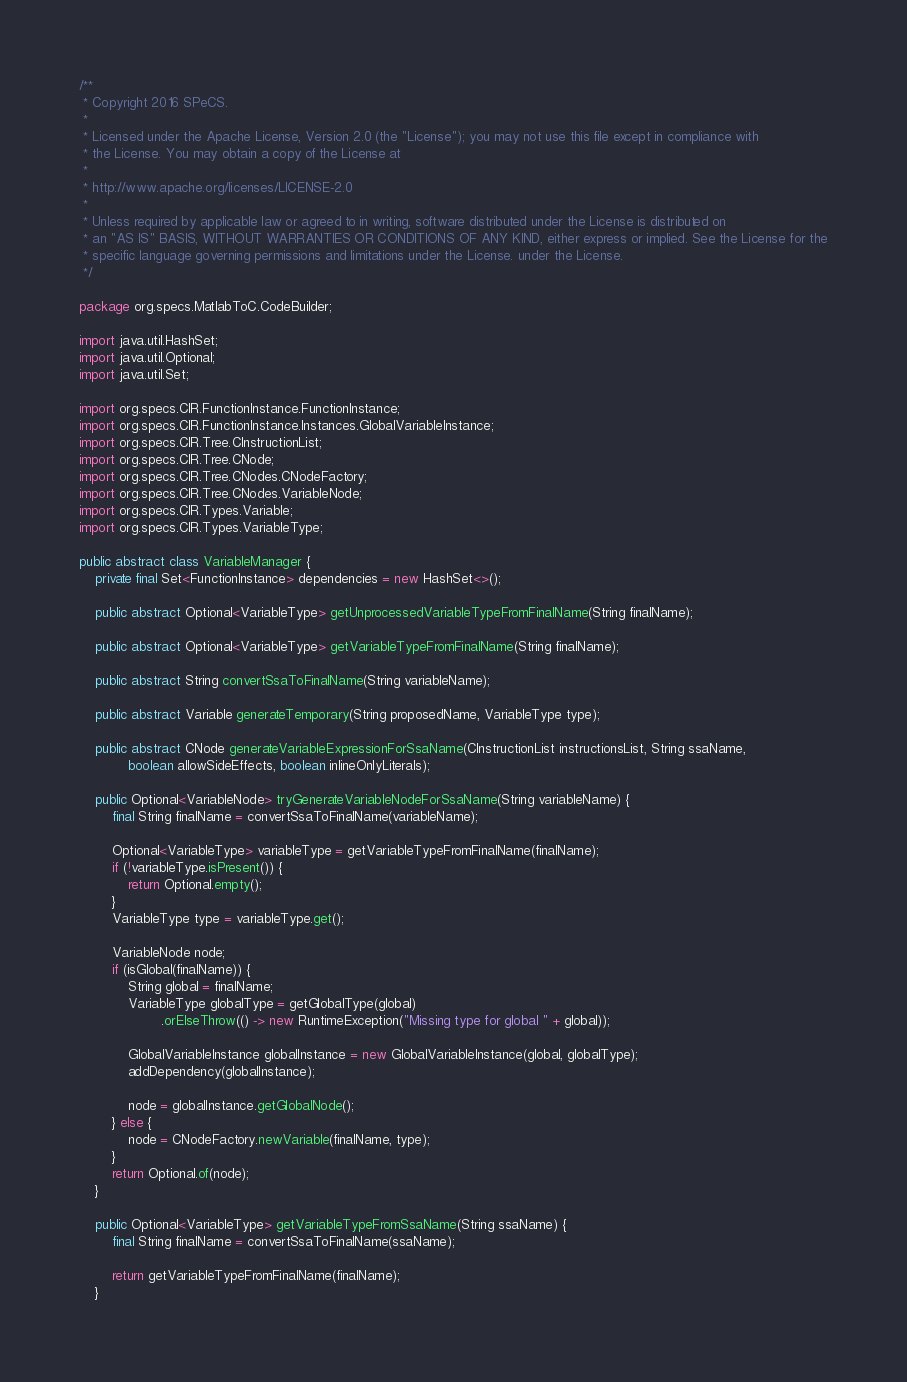Convert code to text. <code><loc_0><loc_0><loc_500><loc_500><_Java_>/**
 * Copyright 2016 SPeCS.
 * 
 * Licensed under the Apache License, Version 2.0 (the "License"); you may not use this file except in compliance with
 * the License. You may obtain a copy of the License at
 * 
 * http://www.apache.org/licenses/LICENSE-2.0
 * 
 * Unless required by applicable law or agreed to in writing, software distributed under the License is distributed on
 * an "AS IS" BASIS, WITHOUT WARRANTIES OR CONDITIONS OF ANY KIND, either express or implied. See the License for the
 * specific language governing permissions and limitations under the License. under the License.
 */

package org.specs.MatlabToC.CodeBuilder;

import java.util.HashSet;
import java.util.Optional;
import java.util.Set;

import org.specs.CIR.FunctionInstance.FunctionInstance;
import org.specs.CIR.FunctionInstance.Instances.GlobalVariableInstance;
import org.specs.CIR.Tree.CInstructionList;
import org.specs.CIR.Tree.CNode;
import org.specs.CIR.Tree.CNodes.CNodeFactory;
import org.specs.CIR.Tree.CNodes.VariableNode;
import org.specs.CIR.Types.Variable;
import org.specs.CIR.Types.VariableType;

public abstract class VariableManager {
    private final Set<FunctionInstance> dependencies = new HashSet<>();

    public abstract Optional<VariableType> getUnprocessedVariableTypeFromFinalName(String finalName);

    public abstract Optional<VariableType> getVariableTypeFromFinalName(String finalName);

    public abstract String convertSsaToFinalName(String variableName);

    public abstract Variable generateTemporary(String proposedName, VariableType type);

    public abstract CNode generateVariableExpressionForSsaName(CInstructionList instructionsList, String ssaName,
            boolean allowSideEffects, boolean inlineOnlyLiterals);

    public Optional<VariableNode> tryGenerateVariableNodeForSsaName(String variableName) {
        final String finalName = convertSsaToFinalName(variableName);

        Optional<VariableType> variableType = getVariableTypeFromFinalName(finalName);
        if (!variableType.isPresent()) {
            return Optional.empty();
        }
        VariableType type = variableType.get();

        VariableNode node;
        if (isGlobal(finalName)) {
            String global = finalName;
            VariableType globalType = getGlobalType(global)
                    .orElseThrow(() -> new RuntimeException("Missing type for global " + global));

            GlobalVariableInstance globalInstance = new GlobalVariableInstance(global, globalType);
            addDependency(globalInstance);

            node = globalInstance.getGlobalNode();
        } else {
            node = CNodeFactory.newVariable(finalName, type);
        }
        return Optional.of(node);
    }

    public Optional<VariableType> getVariableTypeFromSsaName(String ssaName) {
        final String finalName = convertSsaToFinalName(ssaName);

        return getVariableTypeFromFinalName(finalName);
    }
</code> 